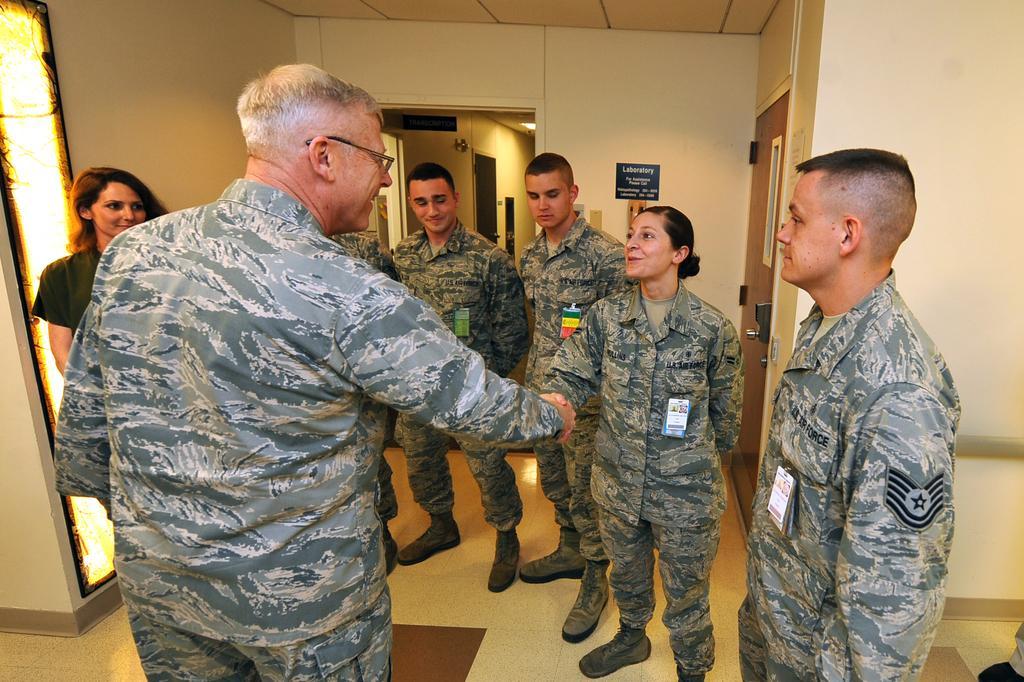Can you describe this image briefly? There is a person in uniform standing on the floor, smiling and shaking hand with woman who is standing in front of him and is smiling and standing on the floor. On the right side, there is other person standing. In the background, there are other persons standing on the floor, there is a door, light attached to the roof, there is a name board attached to the wall and there is roof. 